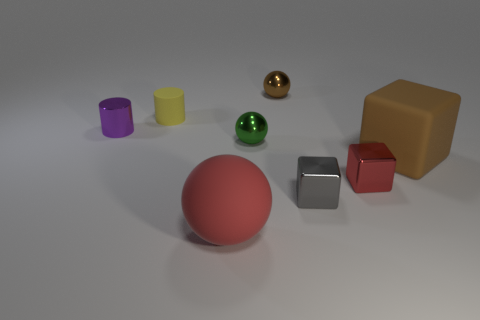Subtract all big spheres. How many spheres are left? 2 Subtract all yellow cylinders. How many cylinders are left? 1 Add 2 small gray matte cubes. How many objects exist? 10 Add 1 big red rubber balls. How many big red rubber balls exist? 2 Subtract 1 red balls. How many objects are left? 7 Subtract all cubes. How many objects are left? 5 Subtract 1 cylinders. How many cylinders are left? 1 Subtract all yellow cylinders. Subtract all cyan spheres. How many cylinders are left? 1 Subtract all blue blocks. How many red balls are left? 1 Subtract all big cyan matte things. Subtract all big brown matte things. How many objects are left? 7 